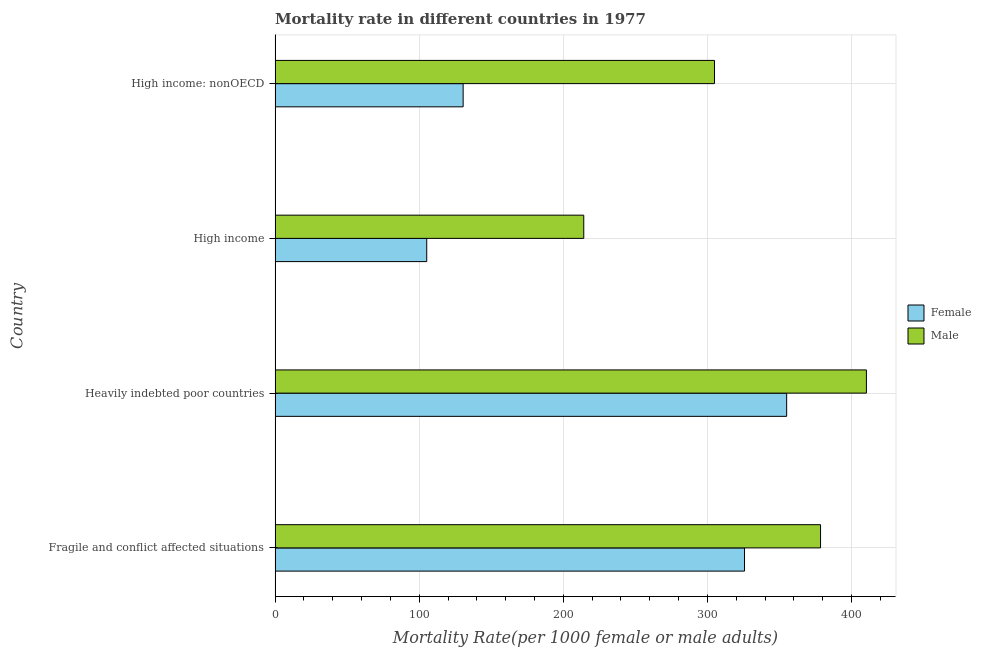How many groups of bars are there?
Your answer should be very brief. 4. What is the female mortality rate in High income: nonOECD?
Offer a terse response. 130.48. Across all countries, what is the maximum female mortality rate?
Provide a succinct answer. 354.94. Across all countries, what is the minimum female mortality rate?
Give a very brief answer. 105.23. In which country was the female mortality rate maximum?
Offer a very short reply. Heavily indebted poor countries. In which country was the male mortality rate minimum?
Your answer should be compact. High income. What is the total male mortality rate in the graph?
Your answer should be very brief. 1307.81. What is the difference between the male mortality rate in Fragile and conflict affected situations and that in High income: nonOECD?
Your answer should be very brief. 73.58. What is the difference between the female mortality rate in High income: nonOECD and the male mortality rate in Fragile and conflict affected situations?
Provide a succinct answer. -247.98. What is the average male mortality rate per country?
Make the answer very short. 326.95. What is the difference between the female mortality rate and male mortality rate in Fragile and conflict affected situations?
Your answer should be very brief. -52.75. What is the ratio of the male mortality rate in Fragile and conflict affected situations to that in Heavily indebted poor countries?
Offer a terse response. 0.92. What is the difference between the highest and the second highest male mortality rate?
Provide a succinct answer. 31.82. What is the difference between the highest and the lowest female mortality rate?
Your response must be concise. 249.72. In how many countries, is the female mortality rate greater than the average female mortality rate taken over all countries?
Ensure brevity in your answer.  2. Is the sum of the female mortality rate in High income and High income: nonOECD greater than the maximum male mortality rate across all countries?
Offer a terse response. No. What does the 2nd bar from the top in High income: nonOECD represents?
Provide a short and direct response. Female. What does the 2nd bar from the bottom in High income represents?
Offer a very short reply. Male. How many countries are there in the graph?
Keep it short and to the point. 4. Does the graph contain any zero values?
Your answer should be very brief. No. Does the graph contain grids?
Ensure brevity in your answer.  Yes. Where does the legend appear in the graph?
Keep it short and to the point. Center right. How many legend labels are there?
Give a very brief answer. 2. What is the title of the graph?
Give a very brief answer. Mortality rate in different countries in 1977. What is the label or title of the X-axis?
Offer a very short reply. Mortality Rate(per 1000 female or male adults). What is the label or title of the Y-axis?
Your response must be concise. Country. What is the Mortality Rate(per 1000 female or male adults) in Female in Fragile and conflict affected situations?
Ensure brevity in your answer.  325.71. What is the Mortality Rate(per 1000 female or male adults) in Male in Fragile and conflict affected situations?
Your answer should be compact. 378.46. What is the Mortality Rate(per 1000 female or male adults) in Female in Heavily indebted poor countries?
Provide a short and direct response. 354.94. What is the Mortality Rate(per 1000 female or male adults) of Male in Heavily indebted poor countries?
Provide a succinct answer. 410.28. What is the Mortality Rate(per 1000 female or male adults) in Female in High income?
Offer a very short reply. 105.23. What is the Mortality Rate(per 1000 female or male adults) in Male in High income?
Offer a terse response. 214.17. What is the Mortality Rate(per 1000 female or male adults) of Female in High income: nonOECD?
Provide a succinct answer. 130.48. What is the Mortality Rate(per 1000 female or male adults) in Male in High income: nonOECD?
Provide a succinct answer. 304.88. Across all countries, what is the maximum Mortality Rate(per 1000 female or male adults) in Female?
Give a very brief answer. 354.94. Across all countries, what is the maximum Mortality Rate(per 1000 female or male adults) in Male?
Offer a very short reply. 410.28. Across all countries, what is the minimum Mortality Rate(per 1000 female or male adults) in Female?
Keep it short and to the point. 105.23. Across all countries, what is the minimum Mortality Rate(per 1000 female or male adults) of Male?
Offer a very short reply. 214.17. What is the total Mortality Rate(per 1000 female or male adults) in Female in the graph?
Provide a short and direct response. 916.36. What is the total Mortality Rate(per 1000 female or male adults) in Male in the graph?
Offer a very short reply. 1307.81. What is the difference between the Mortality Rate(per 1000 female or male adults) of Female in Fragile and conflict affected situations and that in Heavily indebted poor countries?
Make the answer very short. -29.23. What is the difference between the Mortality Rate(per 1000 female or male adults) of Male in Fragile and conflict affected situations and that in Heavily indebted poor countries?
Your answer should be compact. -31.82. What is the difference between the Mortality Rate(per 1000 female or male adults) in Female in Fragile and conflict affected situations and that in High income?
Ensure brevity in your answer.  220.48. What is the difference between the Mortality Rate(per 1000 female or male adults) in Male in Fragile and conflict affected situations and that in High income?
Your answer should be compact. 164.29. What is the difference between the Mortality Rate(per 1000 female or male adults) in Female in Fragile and conflict affected situations and that in High income: nonOECD?
Provide a short and direct response. 195.23. What is the difference between the Mortality Rate(per 1000 female or male adults) in Male in Fragile and conflict affected situations and that in High income: nonOECD?
Provide a short and direct response. 73.58. What is the difference between the Mortality Rate(per 1000 female or male adults) of Female in Heavily indebted poor countries and that in High income?
Offer a very short reply. 249.72. What is the difference between the Mortality Rate(per 1000 female or male adults) of Male in Heavily indebted poor countries and that in High income?
Your answer should be very brief. 196.11. What is the difference between the Mortality Rate(per 1000 female or male adults) in Female in Heavily indebted poor countries and that in High income: nonOECD?
Your answer should be compact. 224.46. What is the difference between the Mortality Rate(per 1000 female or male adults) in Male in Heavily indebted poor countries and that in High income: nonOECD?
Make the answer very short. 105.4. What is the difference between the Mortality Rate(per 1000 female or male adults) of Female in High income and that in High income: nonOECD?
Provide a succinct answer. -25.25. What is the difference between the Mortality Rate(per 1000 female or male adults) in Male in High income and that in High income: nonOECD?
Your response must be concise. -90.71. What is the difference between the Mortality Rate(per 1000 female or male adults) in Female in Fragile and conflict affected situations and the Mortality Rate(per 1000 female or male adults) in Male in Heavily indebted poor countries?
Provide a succinct answer. -84.57. What is the difference between the Mortality Rate(per 1000 female or male adults) of Female in Fragile and conflict affected situations and the Mortality Rate(per 1000 female or male adults) of Male in High income?
Your answer should be compact. 111.54. What is the difference between the Mortality Rate(per 1000 female or male adults) in Female in Fragile and conflict affected situations and the Mortality Rate(per 1000 female or male adults) in Male in High income: nonOECD?
Provide a succinct answer. 20.83. What is the difference between the Mortality Rate(per 1000 female or male adults) in Female in Heavily indebted poor countries and the Mortality Rate(per 1000 female or male adults) in Male in High income?
Give a very brief answer. 140.77. What is the difference between the Mortality Rate(per 1000 female or male adults) of Female in Heavily indebted poor countries and the Mortality Rate(per 1000 female or male adults) of Male in High income: nonOECD?
Give a very brief answer. 50.06. What is the difference between the Mortality Rate(per 1000 female or male adults) in Female in High income and the Mortality Rate(per 1000 female or male adults) in Male in High income: nonOECD?
Keep it short and to the point. -199.66. What is the average Mortality Rate(per 1000 female or male adults) in Female per country?
Your answer should be very brief. 229.09. What is the average Mortality Rate(per 1000 female or male adults) of Male per country?
Ensure brevity in your answer.  326.95. What is the difference between the Mortality Rate(per 1000 female or male adults) of Female and Mortality Rate(per 1000 female or male adults) of Male in Fragile and conflict affected situations?
Provide a succinct answer. -52.75. What is the difference between the Mortality Rate(per 1000 female or male adults) of Female and Mortality Rate(per 1000 female or male adults) of Male in Heavily indebted poor countries?
Your response must be concise. -55.34. What is the difference between the Mortality Rate(per 1000 female or male adults) in Female and Mortality Rate(per 1000 female or male adults) in Male in High income?
Keep it short and to the point. -108.95. What is the difference between the Mortality Rate(per 1000 female or male adults) of Female and Mortality Rate(per 1000 female or male adults) of Male in High income: nonOECD?
Provide a succinct answer. -174.41. What is the ratio of the Mortality Rate(per 1000 female or male adults) in Female in Fragile and conflict affected situations to that in Heavily indebted poor countries?
Your answer should be very brief. 0.92. What is the ratio of the Mortality Rate(per 1000 female or male adults) of Male in Fragile and conflict affected situations to that in Heavily indebted poor countries?
Provide a short and direct response. 0.92. What is the ratio of the Mortality Rate(per 1000 female or male adults) of Female in Fragile and conflict affected situations to that in High income?
Provide a short and direct response. 3.1. What is the ratio of the Mortality Rate(per 1000 female or male adults) of Male in Fragile and conflict affected situations to that in High income?
Provide a succinct answer. 1.77. What is the ratio of the Mortality Rate(per 1000 female or male adults) of Female in Fragile and conflict affected situations to that in High income: nonOECD?
Give a very brief answer. 2.5. What is the ratio of the Mortality Rate(per 1000 female or male adults) in Male in Fragile and conflict affected situations to that in High income: nonOECD?
Your answer should be compact. 1.24. What is the ratio of the Mortality Rate(per 1000 female or male adults) of Female in Heavily indebted poor countries to that in High income?
Keep it short and to the point. 3.37. What is the ratio of the Mortality Rate(per 1000 female or male adults) of Male in Heavily indebted poor countries to that in High income?
Your response must be concise. 1.92. What is the ratio of the Mortality Rate(per 1000 female or male adults) of Female in Heavily indebted poor countries to that in High income: nonOECD?
Give a very brief answer. 2.72. What is the ratio of the Mortality Rate(per 1000 female or male adults) of Male in Heavily indebted poor countries to that in High income: nonOECD?
Offer a very short reply. 1.35. What is the ratio of the Mortality Rate(per 1000 female or male adults) of Female in High income to that in High income: nonOECD?
Keep it short and to the point. 0.81. What is the ratio of the Mortality Rate(per 1000 female or male adults) of Male in High income to that in High income: nonOECD?
Your answer should be very brief. 0.7. What is the difference between the highest and the second highest Mortality Rate(per 1000 female or male adults) in Female?
Ensure brevity in your answer.  29.23. What is the difference between the highest and the second highest Mortality Rate(per 1000 female or male adults) of Male?
Offer a terse response. 31.82. What is the difference between the highest and the lowest Mortality Rate(per 1000 female or male adults) in Female?
Give a very brief answer. 249.72. What is the difference between the highest and the lowest Mortality Rate(per 1000 female or male adults) in Male?
Your answer should be very brief. 196.11. 